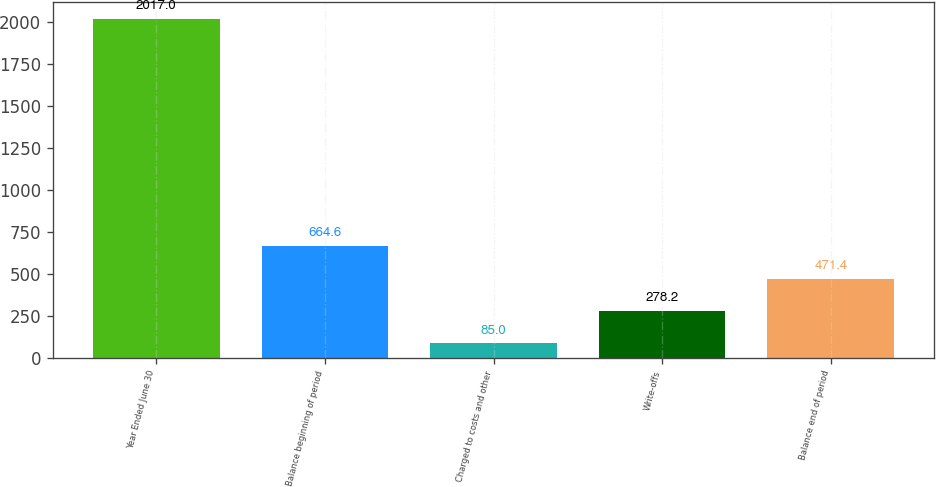<chart> <loc_0><loc_0><loc_500><loc_500><bar_chart><fcel>Year Ended June 30<fcel>Balance beginning of period<fcel>Charged to costs and other<fcel>Write-offs<fcel>Balance end of period<nl><fcel>2017<fcel>664.6<fcel>85<fcel>278.2<fcel>471.4<nl></chart> 